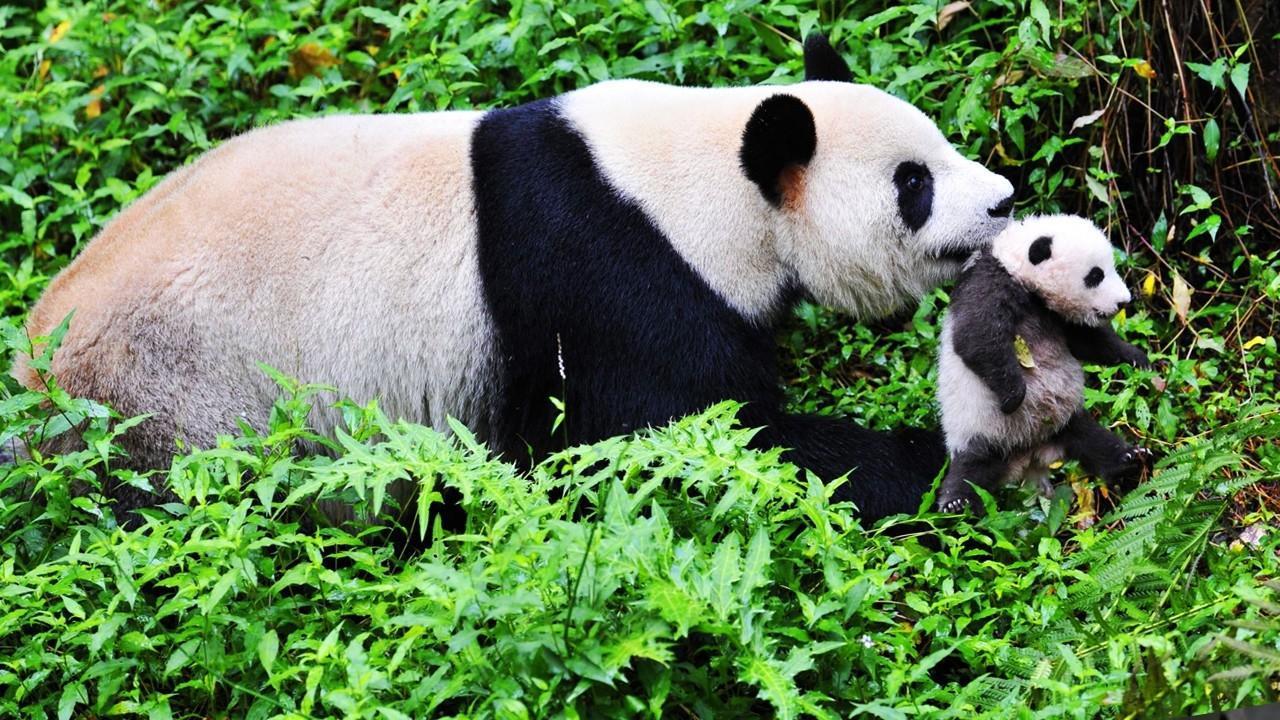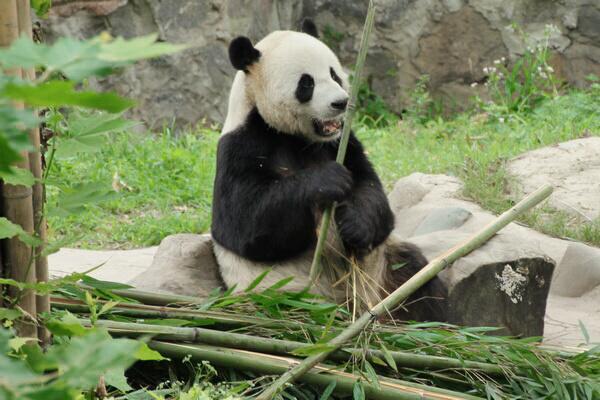The first image is the image on the left, the second image is the image on the right. Considering the images on both sides, is "Each panda in the image, whose mouth can clearly be seen, is currently eating bamboo." valid? Answer yes or no. No. 